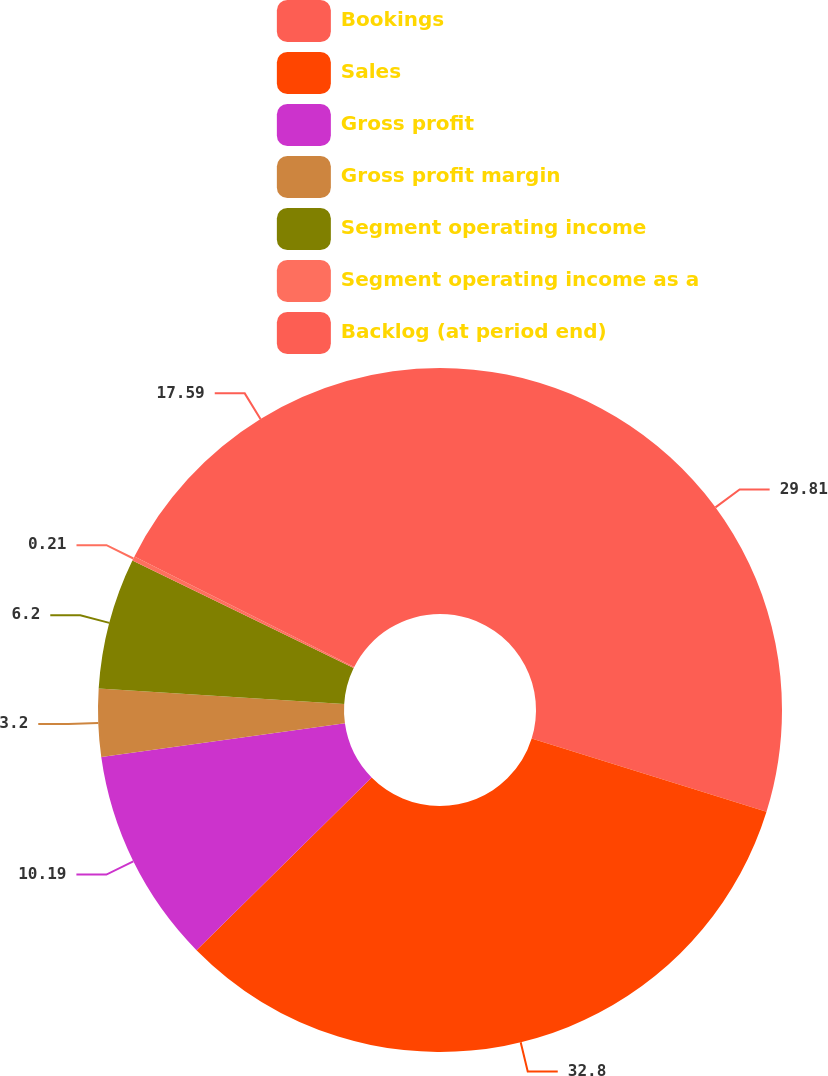Convert chart. <chart><loc_0><loc_0><loc_500><loc_500><pie_chart><fcel>Bookings<fcel>Sales<fcel>Gross profit<fcel>Gross profit margin<fcel>Segment operating income<fcel>Segment operating income as a<fcel>Backlog (at period end)<nl><fcel>29.81%<fcel>32.8%<fcel>10.19%<fcel>3.2%<fcel>6.2%<fcel>0.21%<fcel>17.59%<nl></chart> 